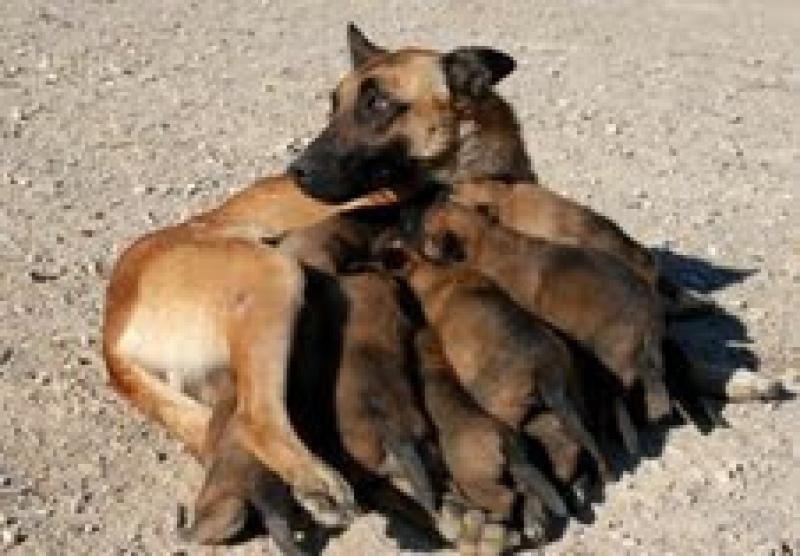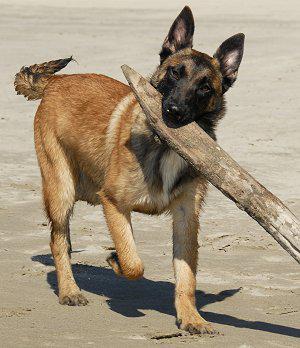The first image is the image on the left, the second image is the image on the right. For the images shown, is this caption "The dog in the image on the right is wearing a collar." true? Answer yes or no. No. The first image is the image on the left, the second image is the image on the right. Evaluate the accuracy of this statement regarding the images: "One image contains a puppy standing on all fours, and the other contains a dog with upright ears wearing a red collar.". Is it true? Answer yes or no. No. 